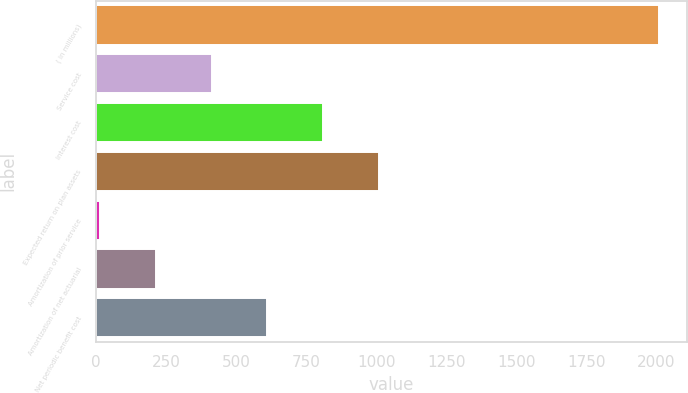<chart> <loc_0><loc_0><loc_500><loc_500><bar_chart><fcel>( in millions)<fcel>Service cost<fcel>Interest cost<fcel>Expected return on plan assets<fcel>Amortization of prior service<fcel>Amortization of net actuarial<fcel>Net periodic benefit cost<nl><fcel>2009<fcel>412.2<fcel>811.4<fcel>1011<fcel>13<fcel>212.6<fcel>611.8<nl></chart> 